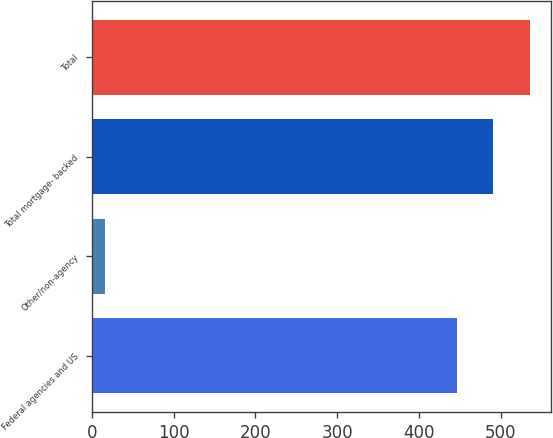Convert chart to OTSL. <chart><loc_0><loc_0><loc_500><loc_500><bar_chart><fcel>Federal agencies and US<fcel>Other/non-agency<fcel>Total mortgage- backed<fcel>Total<nl><fcel>446<fcel>16<fcel>490.6<fcel>535.2<nl></chart> 